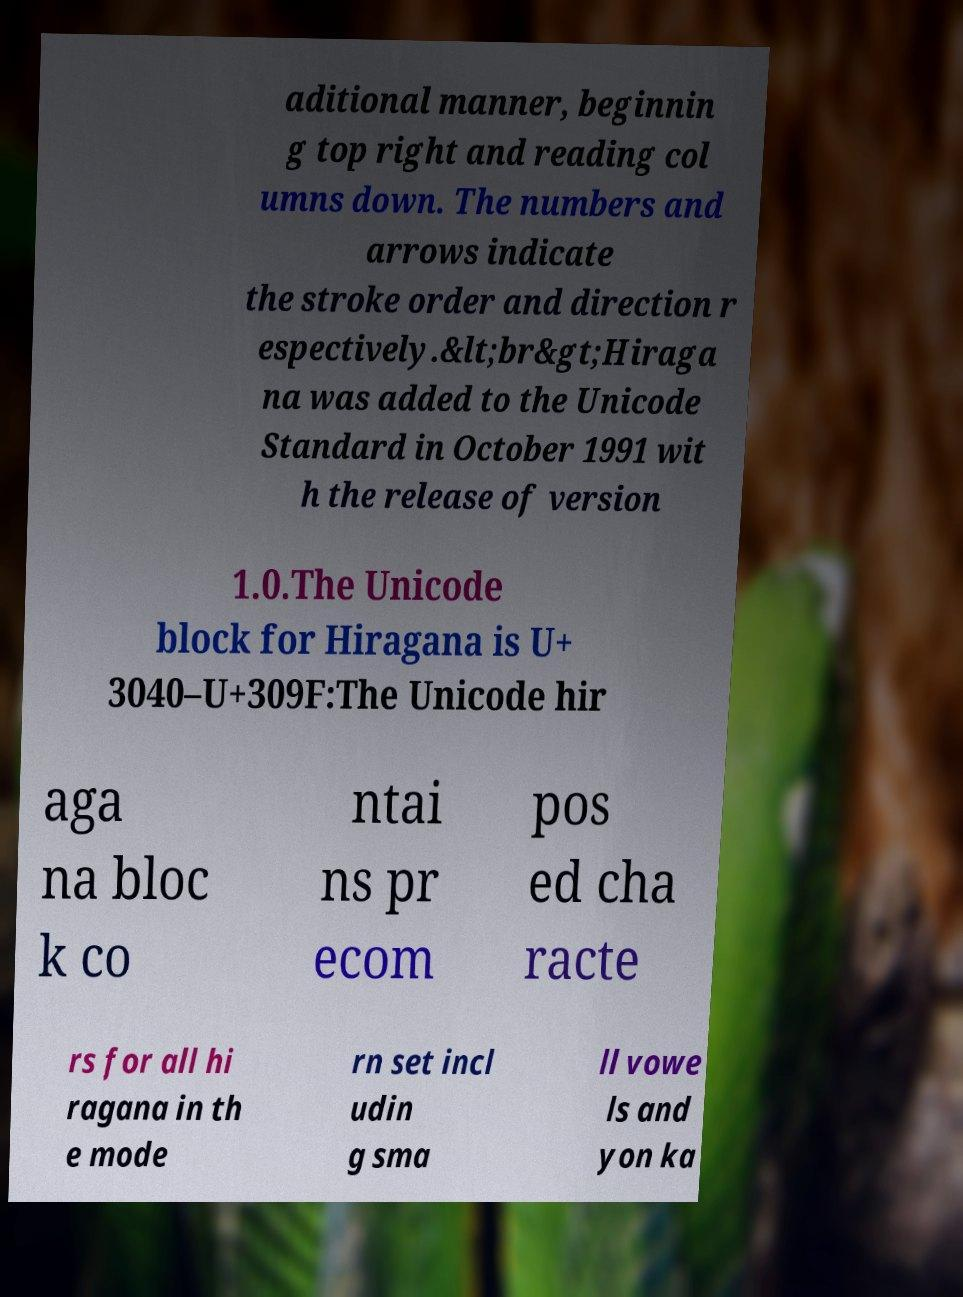Please identify and transcribe the text found in this image. aditional manner, beginnin g top right and reading col umns down. The numbers and arrows indicate the stroke order and direction r espectively.&lt;br&gt;Hiraga na was added to the Unicode Standard in October 1991 wit h the release of version 1.0.The Unicode block for Hiragana is U+ 3040–U+309F:The Unicode hir aga na bloc k co ntai ns pr ecom pos ed cha racte rs for all hi ragana in th e mode rn set incl udin g sma ll vowe ls and yon ka 